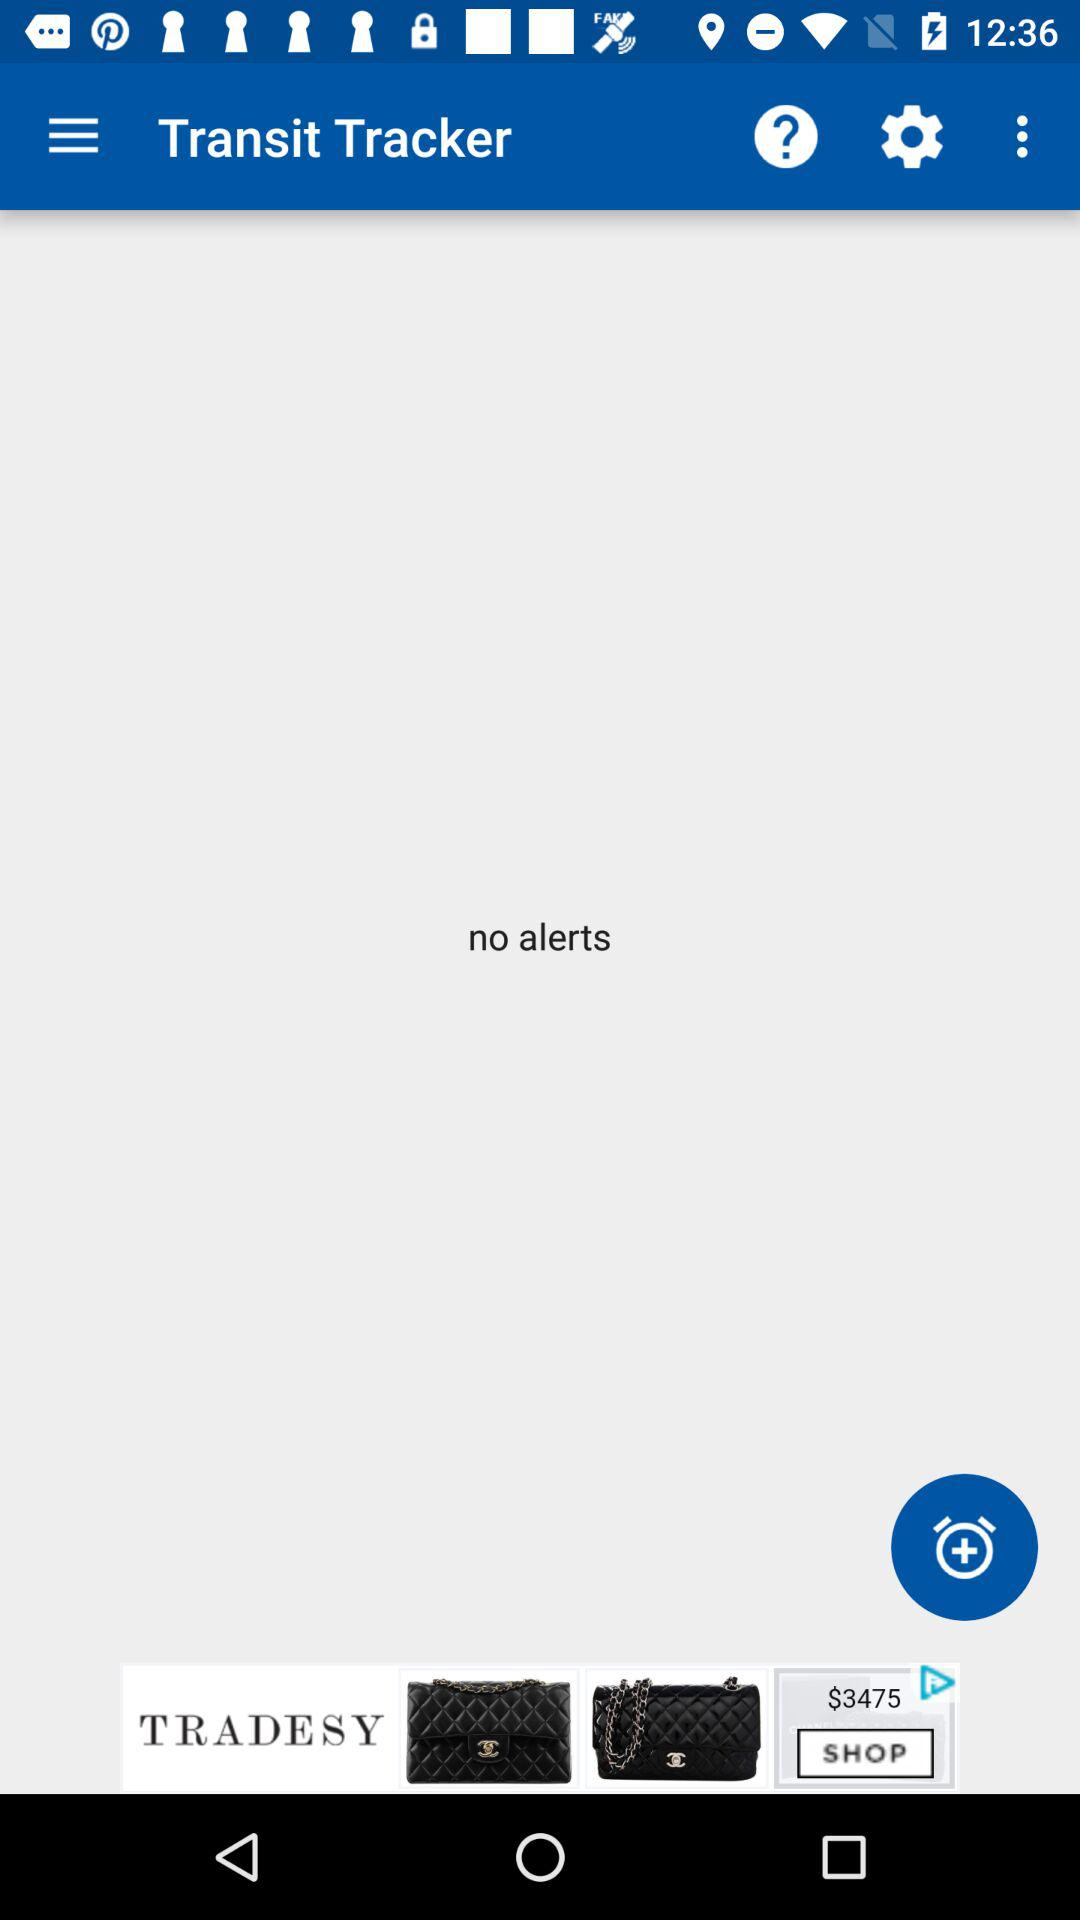What is the application name? The application name is "Transit Tracker". 